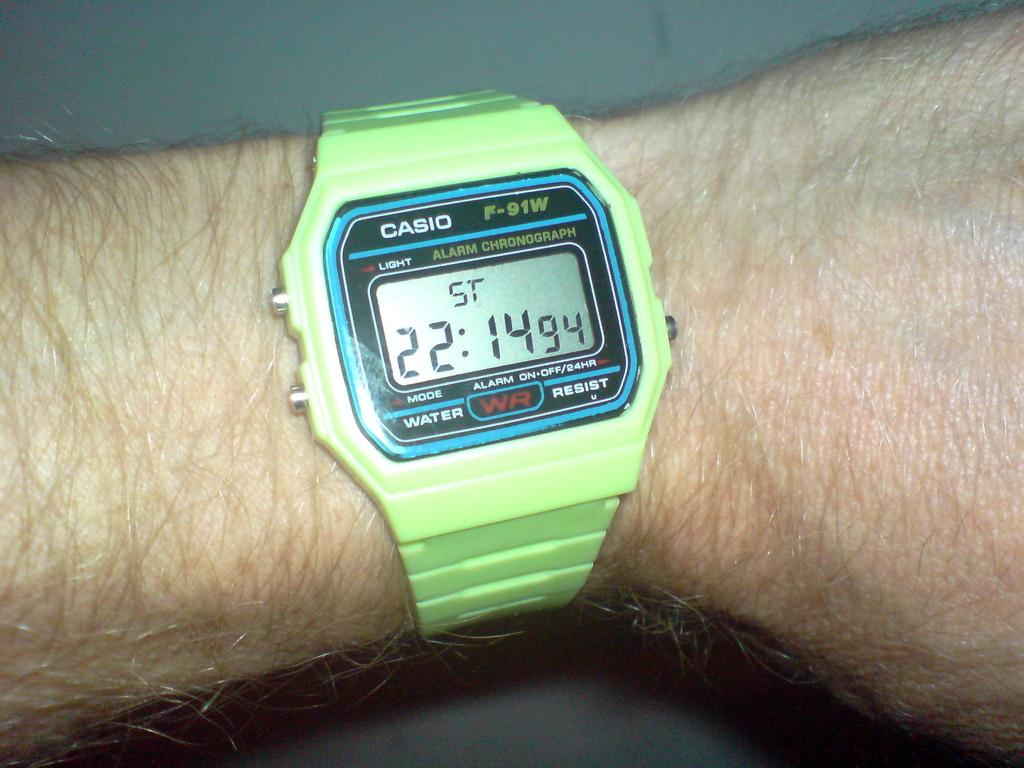Provide a one-sentence caption for the provided image. A wrist wearing a green Casio watch the time reads 22:14. 